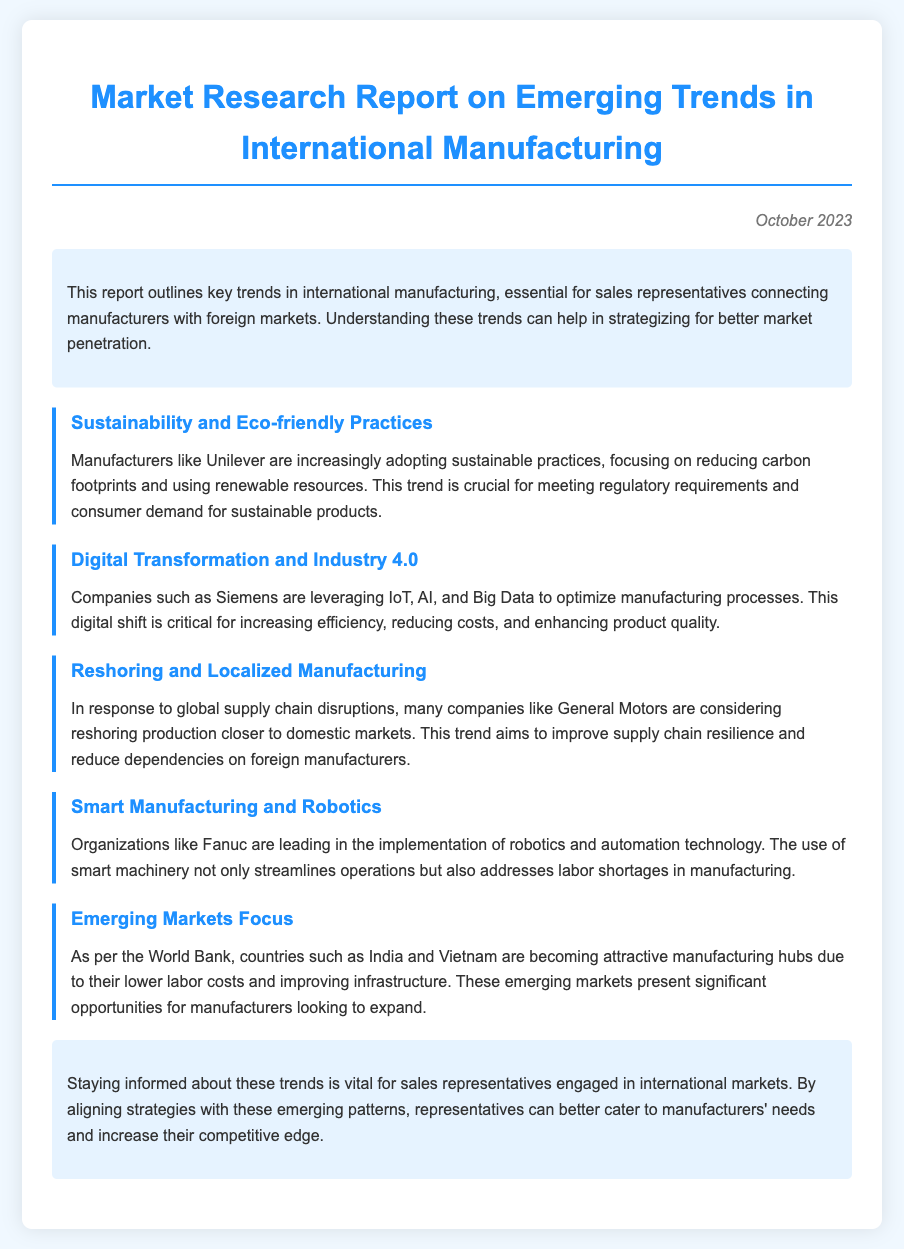What is the title of the report? The title of the report is clearly stated at the top of the document.
Answer: Market Research Report on Emerging Trends in International Manufacturing When was the report published? The publication date is provided at the top right corner of the document.
Answer: October 2023 Which company is mentioned as adopting sustainable practices? The document lists specific companies that are adopting certain practices; one is highlighted in the sustainability section.
Answer: Unilever What technology is emphasized in the digital transformation trend? The digital transformation section identifies certain technologies used by companies to enhance processes.
Answer: IoT, AI, and Big Data Which country is mentioned as an emerging manufacturing hub due to lower labor costs? The emerging markets section mentions specific countries known for attractive manufacturing conditions.
Answer: India What is the trend related to supply chain disruptions? The document describes a specific response to supply chain issues affecting production locations.
Answer: Reshoring Which organization is noted for leading in smart manufacturing? The report highlights a specific organization recognized for its advancements in automation and robotics.
Answer: Fanuc Why is staying informed about these trends important for sales representatives? The conclusion provides insight into the significance of being aware of these trends for enhancing market competitiveness.
Answer: Competitive edge 